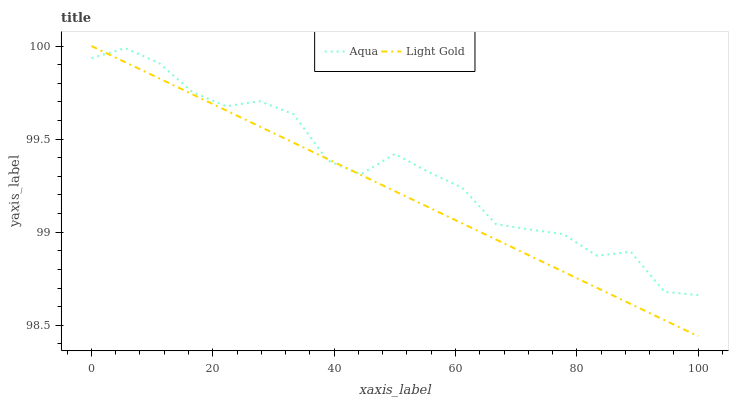Does Aqua have the minimum area under the curve?
Answer yes or no. No. Is Aqua the smoothest?
Answer yes or no. No. Does Aqua have the lowest value?
Answer yes or no. No. Does Aqua have the highest value?
Answer yes or no. No. 